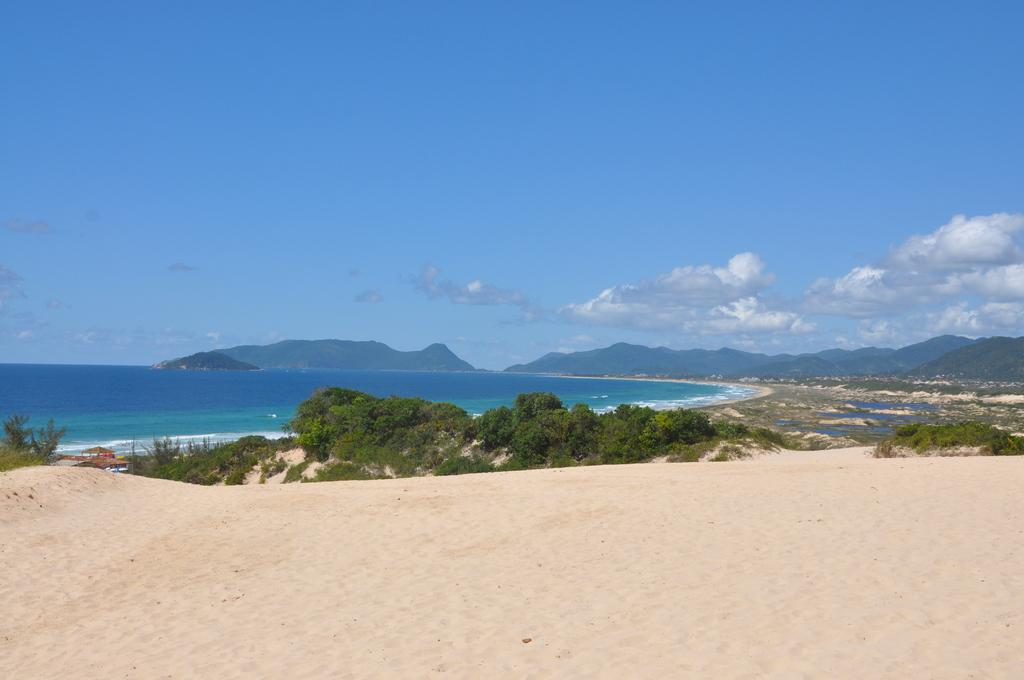What is in the foreground of the image? There is sand and trees in the foreground of the image. What else can be seen in the foreground of the image? There are vehicles in the foreground of the image. What is visible in the middle of the image? There is blue water and mountains in the middle of the image. What is visible at the top of the image? The sky is visible at the top of the image. Where was the image taken? The image was taken near a sandy beach. Can you see a scarf being used as a place marker in the image? There is no scarf or place marker present in the image. What type of afterthought is depicted in the image? There is no afterthought depicted in the image; it is a scene of a sandy beach with trees, vehicles, water, mountains, and sky. 